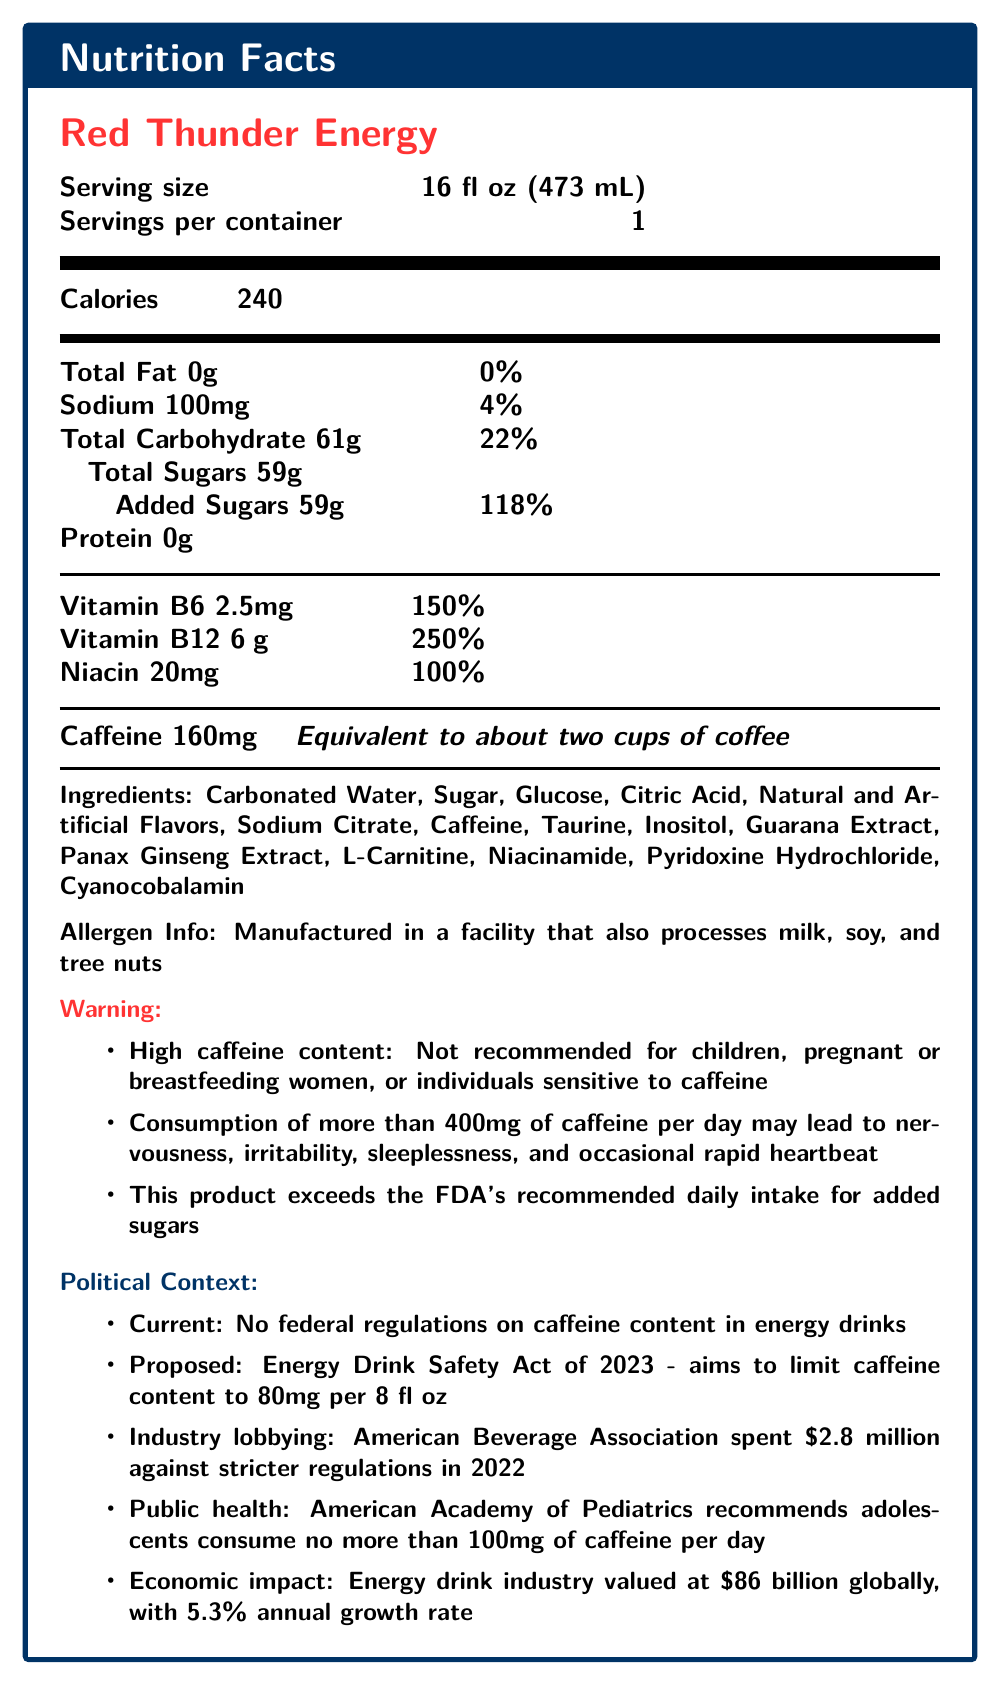What is the serving size of Red Thunder Energy? The serving size is listed near the top of the document as “Serving size: 16 fl oz (473 mL).”
Answer: 16 fl oz (473 mL) How many calories are in one serving of Red Thunder Energy? The Calories section of the nutrition facts states that there are 240 calories per serving.
Answer: 240 How much caffeine is in one serving of Red Thunder Energy? The amount of caffeine is listed in bold under the ingredients section as “Caffeine 160mg.”
Answer: 160mg What is the recommended daily limit for caffeine consumption according to the document? The regulatory notes mention that consumption of more than 400mg of caffeine per day may lead to negative health effects.
Answer: 400mg How many grams of sugar are added to Red Thunder Energy? The document specifies “Added Sugars 59g” next to the Total Sugars section.
Answer: 59g Which of the following vitamins is present in the highest daily value percentage in Red Thunder Energy? A. Vitamin B6 B. Vitamin B12 C. Niacin Vitamin B12 has a daily value percentage of 250%, higher than Vitamin B6’s 150% and Niacin’s 100%.
Answer: B. Vitamin B12 According to the document, energy drinks like Red Thunder Energy are not recommended for which groups of people? A. Children B. People with caffeine sensitivity C. Pregnant or breastfeeding women D. All of the above The warning section explicitly states that Red Thunder Energy is not recommended for children, pregnant or breastfeeding women, or individuals sensitive to caffeine.
Answer: D. All of the above Should adolescents consume Red Thunder Energy according to the American Academy of Pediatrics? The public health concern note mentions that the American Academy of Pediatrics recommends adolescents consume no more than 100mg of caffeine per day.
Answer: No What percentage of the daily value for added sugars does Red Thunder Energy contain? The Total Sugars section lists “Added Sugars 59g” and indicates it is 118% of the daily value.
Answer: 118% How many servings are in a container of Red Thunder Energy? The serving information states that there is 1 serving per container.
Answer: 1 Does Red Thunder Energy contain any protein? The nutrition facts detail that Protein is 0g.
Answer: No Summarize the main information provided in the Nutrition Facts Label for Red Thunder Energy. This summary covers the primary nutritional values, ingredients, warnings, and political context, providing a comprehensive view of what Red Thunder Energy contains and its broader implications.
Answer: The Nutrition Facts Label for Red Thunder Energy details a 16 fl oz serving size with 240 calories, 0 grams of fat, 100 mg of sodium, 61 grams of total carbohydrates, 59 grams of total sugars, and 160 mg of caffeine. It has high levels of Vitamin B6, Vitamin B12, and Niacin. It is not recommended for children, pregnant or breastfeeding women, or those sensitive to caffeine, and it warns against excessive caffeine consumption. The document also includes broader political and regulatory context about energy drinks. What is the value of the energy drink industry globally? The political context section states that the energy drink industry is valued at $86 billion globally.
Answer: $86 billion What is the growth rate of the energy drink industry mentioned in the document? The economic impact section notes a 5.3% annual growth rate for the energy drink industry.
Answer: 5.3% annual growth rate What is the main ingredient listed in Red Thunder Energy? The ingredients list begins with “Carbonated Water,” indicating it is the primary ingredient.
Answer: Carbonated Water What percentage of Vitamin B6 does Red Thunder Energy provide per serving? The vitamins and minerals section states that Vitamin B6 is provided at 150% of the daily value per serving.
Answer: 150% 